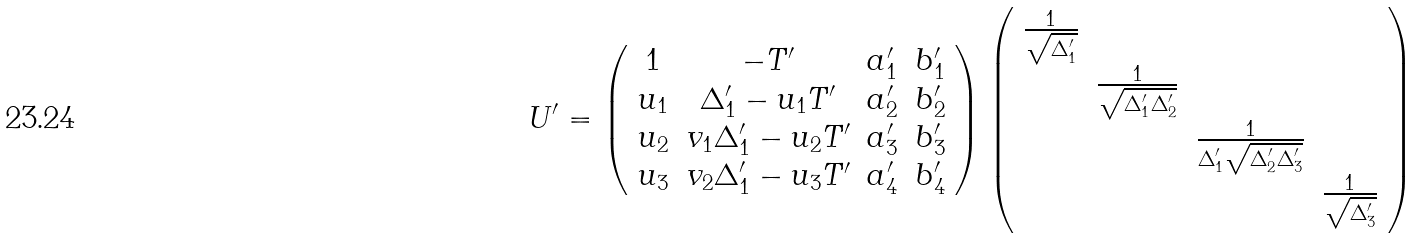Convert formula to latex. <formula><loc_0><loc_0><loc_500><loc_500>U ^ { \prime } = \left ( \begin{array} { c c c c } 1 & - T ^ { \prime } & a _ { 1 } ^ { \prime } & b _ { 1 } ^ { \prime } \\ u _ { 1 } & \Delta _ { 1 } ^ { \prime } - u _ { 1 } T ^ { \prime } & a _ { 2 } ^ { \prime } & b _ { 2 } ^ { \prime } \\ u _ { 2 } & v _ { 1 } \Delta _ { 1 } ^ { \prime } - u _ { 2 } T ^ { \prime } & a _ { 3 } ^ { \prime } & b _ { 3 } ^ { \prime } \\ u _ { 3 } & v _ { 2 } \Delta _ { 1 } ^ { \prime } - u _ { 3 } T ^ { \prime } & a _ { 4 } ^ { \prime } & b _ { 4 } ^ { \prime } \end{array} \right ) \left ( \begin{array} { c c c c } \frac { 1 } { \sqrt { \Delta _ { 1 } ^ { \prime } } } & & \\ & \frac { 1 } { \sqrt { \Delta _ { 1 } ^ { \prime } \Delta _ { 2 } ^ { \prime } } } & \\ & & \frac { 1 } { \Delta _ { 1 } ^ { \prime } \sqrt { \Delta _ { 2 } ^ { \prime } \Delta _ { 3 } ^ { \prime } } } \\ & & & \frac { 1 } { \sqrt { \Delta _ { 3 } ^ { \prime } } } \end{array} \right )</formula> 